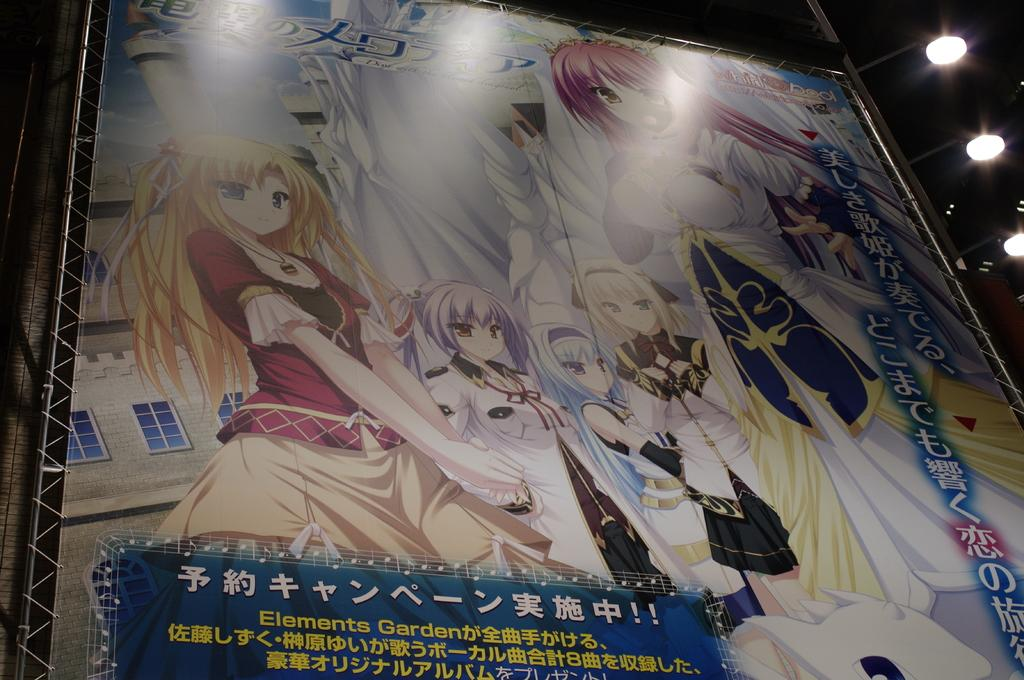What is the main feature of the image? There is a bigger cartoon hoarding in the image. Where can you find text in the image? The text is located at the bottom left corner of the image. What else can be seen in the image besides the hoarding and text? There are lights visible in the image. How many cherries are on the basketball hoop in the image? There is no basketball hoop or cherries present in the image. What color is the goldfish swimming near the lights in the image? There is no goldfish present in the image. 